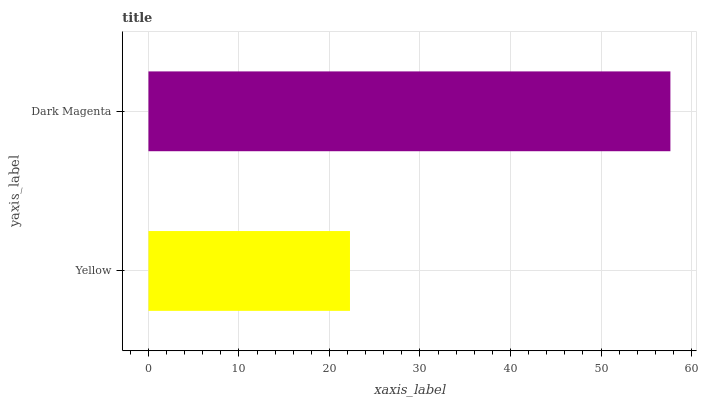Is Yellow the minimum?
Answer yes or no. Yes. Is Dark Magenta the maximum?
Answer yes or no. Yes. Is Dark Magenta the minimum?
Answer yes or no. No. Is Dark Magenta greater than Yellow?
Answer yes or no. Yes. Is Yellow less than Dark Magenta?
Answer yes or no. Yes. Is Yellow greater than Dark Magenta?
Answer yes or no. No. Is Dark Magenta less than Yellow?
Answer yes or no. No. Is Dark Magenta the high median?
Answer yes or no. Yes. Is Yellow the low median?
Answer yes or no. Yes. Is Yellow the high median?
Answer yes or no. No. Is Dark Magenta the low median?
Answer yes or no. No. 